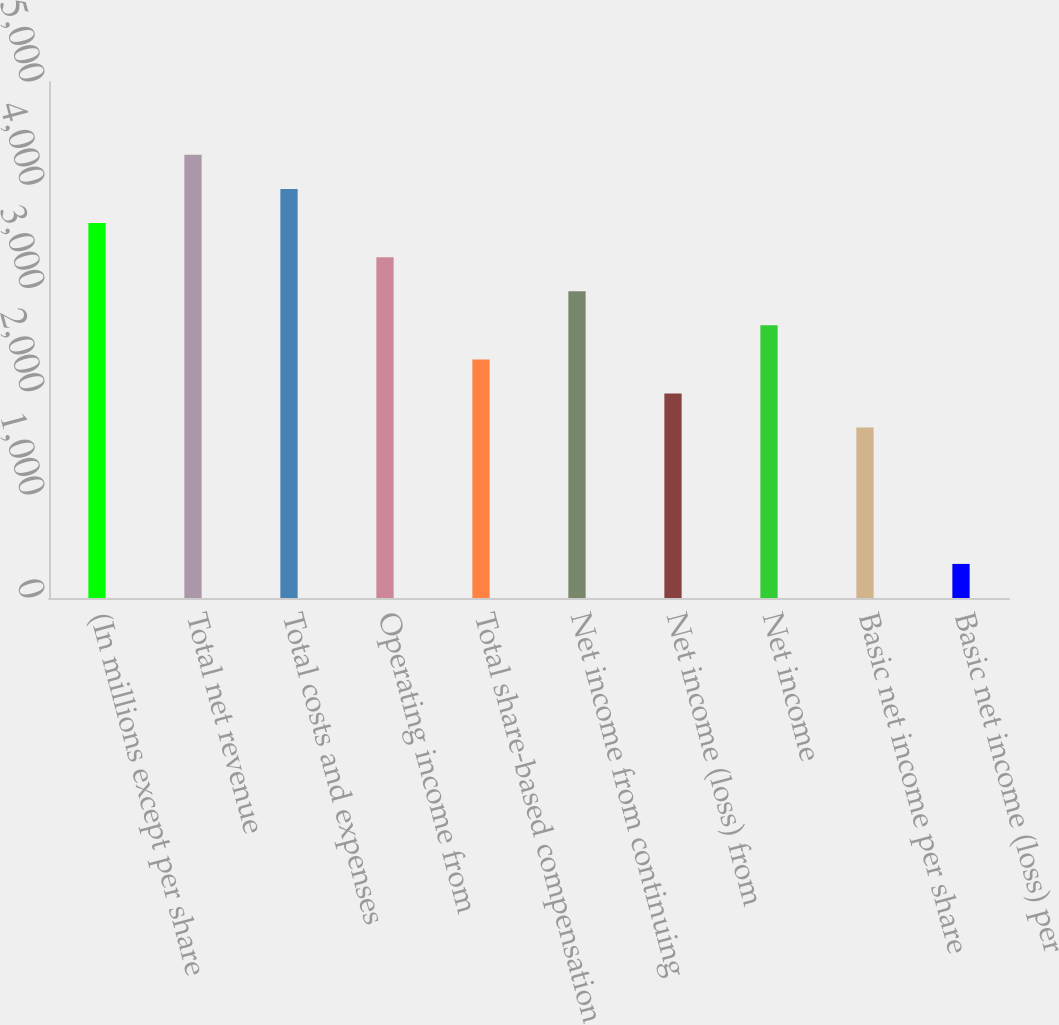<chart> <loc_0><loc_0><loc_500><loc_500><bar_chart><fcel>(In millions except per share<fcel>Total net revenue<fcel>Total costs and expenses<fcel>Operating income from<fcel>Total share-based compensation<fcel>Net income from continuing<fcel>Net income (loss) from<fcel>Net income<fcel>Basic net income per share<fcel>Basic net income (loss) per<nl><fcel>3633.31<fcel>4293.91<fcel>3963.61<fcel>3303.01<fcel>2312.11<fcel>2972.71<fcel>1981.81<fcel>2642.41<fcel>1651.51<fcel>330.31<nl></chart> 